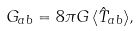Convert formula to latex. <formula><loc_0><loc_0><loc_500><loc_500>G _ { a b } = 8 \pi G \, \langle \hat { T } _ { a b } \rangle ,</formula> 